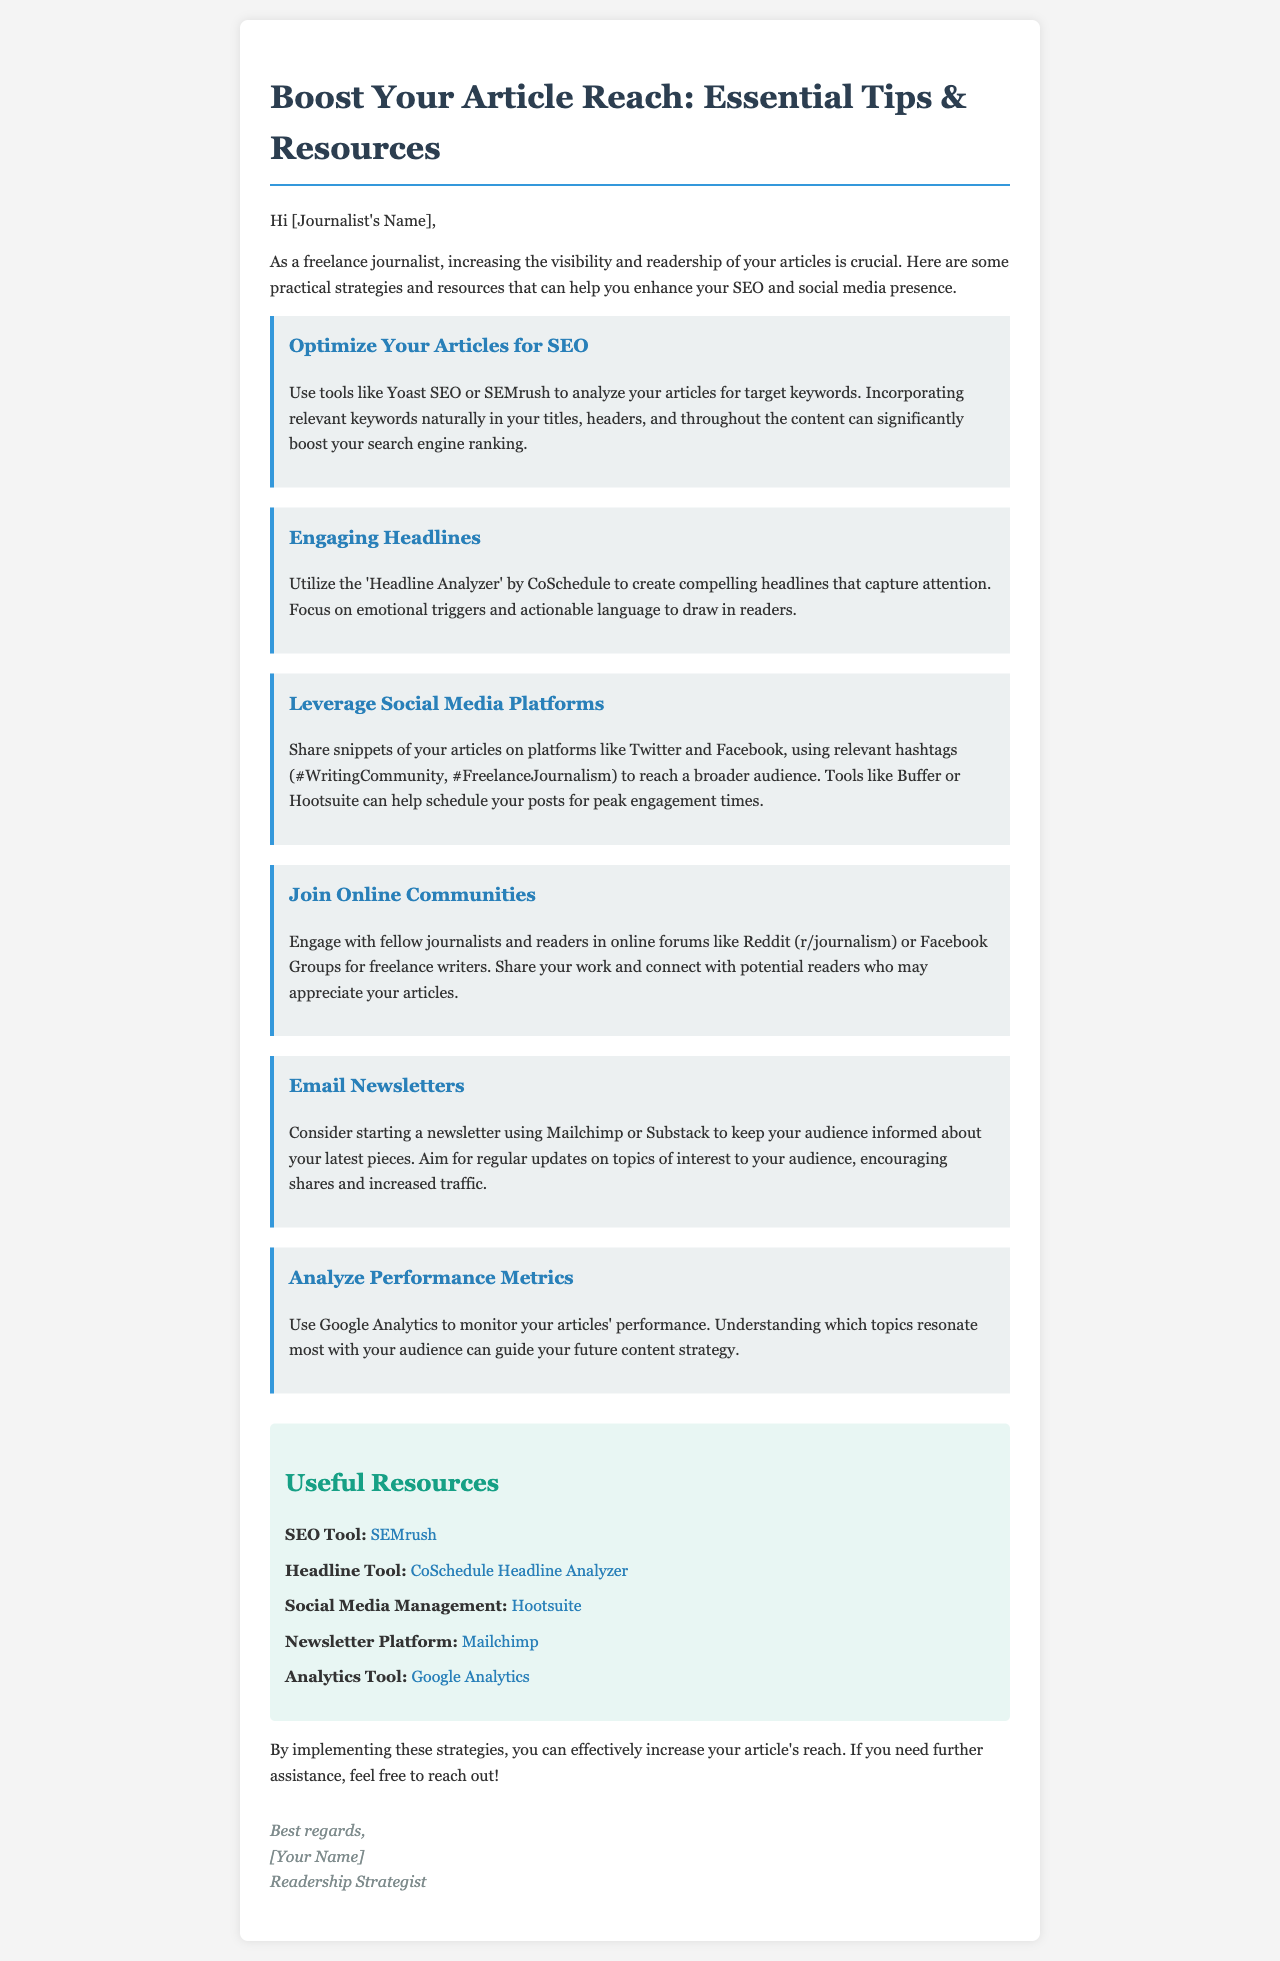What is the title of the document? The title of the document is provided in the `<title>` tag of the HTML code.
Answer: Boost Your Article Reach: Essential Tips & Resources Who is the email addressed to? The greeting indicates that the email is personalized and directed to the freelance journalist by name.
Answer: [Journalist's Name] What is one tool mentioned for analyzing articles for SEO? The document mentions tools that can help with SEO analysis and provides specific examples.
Answer: SEMrush Which social media management tool is suggested? The resources section lists a tool specifically for managing social media posts.
Answer: Hootsuite How many tips are provided in the email? The number of tips can be determined by counting how many distinct tips are presented in the document.
Answer: Six What type of content is recommended to share on social media? The tips suggest specific actions that can enhance engagement and visibility.
Answer: Snippets of your articles What platform can be used for email newsletters? The resources section contains a specific platform that allows for the creation of email newsletters.
Answer: Mailchimp What metric tracking tool is suggested for analyzing article performance? A specific tool is recommended for monitoring performance metrics in the document.
Answer: Google Analytics 